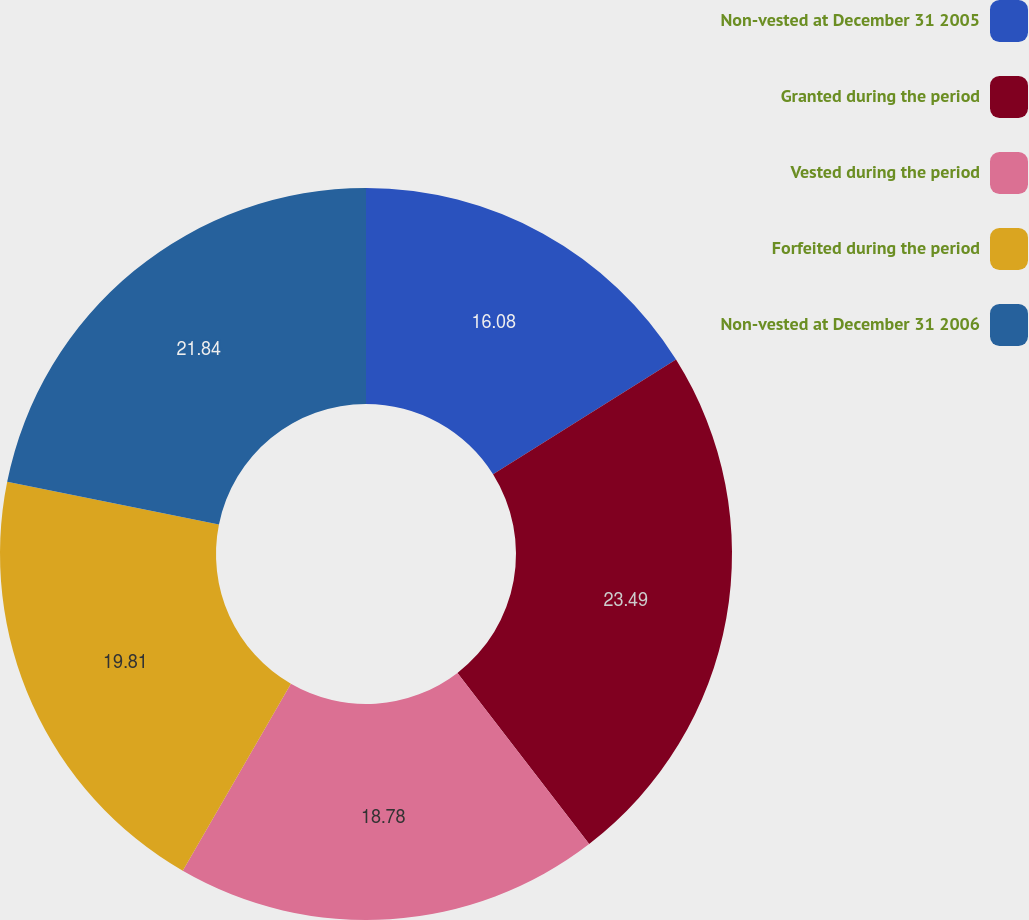<chart> <loc_0><loc_0><loc_500><loc_500><pie_chart><fcel>Non-vested at December 31 2005<fcel>Granted during the period<fcel>Vested during the period<fcel>Forfeited during the period<fcel>Non-vested at December 31 2006<nl><fcel>16.08%<fcel>23.48%<fcel>18.78%<fcel>19.81%<fcel>21.84%<nl></chart> 